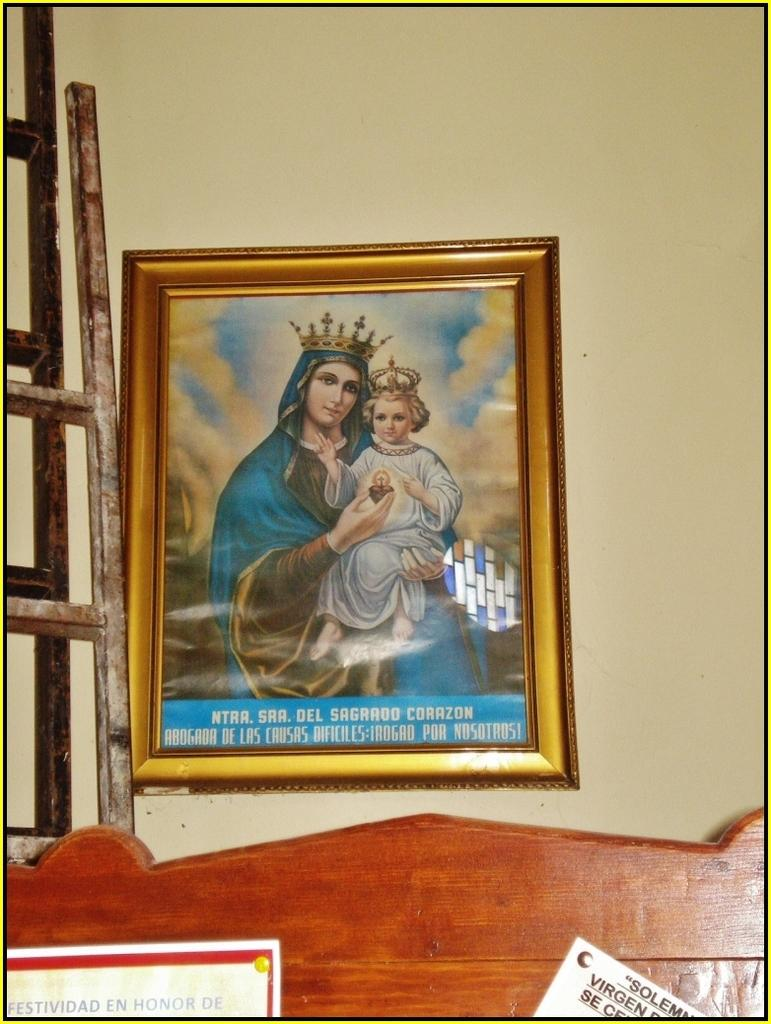<image>
Give a short and clear explanation of the subsequent image. a religious picture of Sra Del Sagrado Corazon 